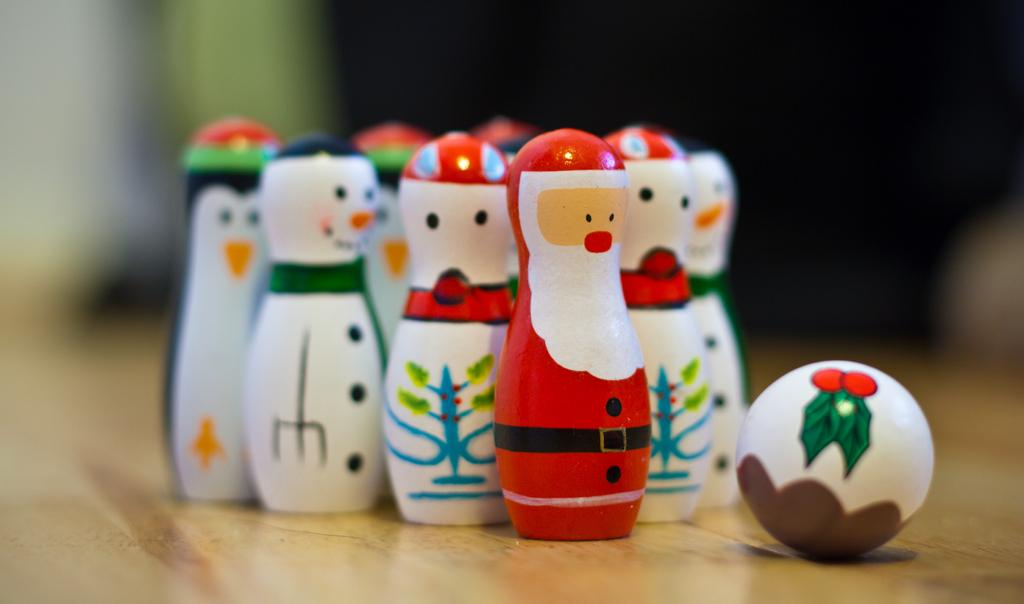What object can be seen in the image that is small in size? There is a small pin in the image. Where is the pin located? The pin is kept on a table. What other object is near the pin? There is a ball near the pin. How would you describe the background of the image? The background of the image appears blurry. What time of day is it in the image? The provided facts do not mention the time of day, so it cannot be determined from the image. 